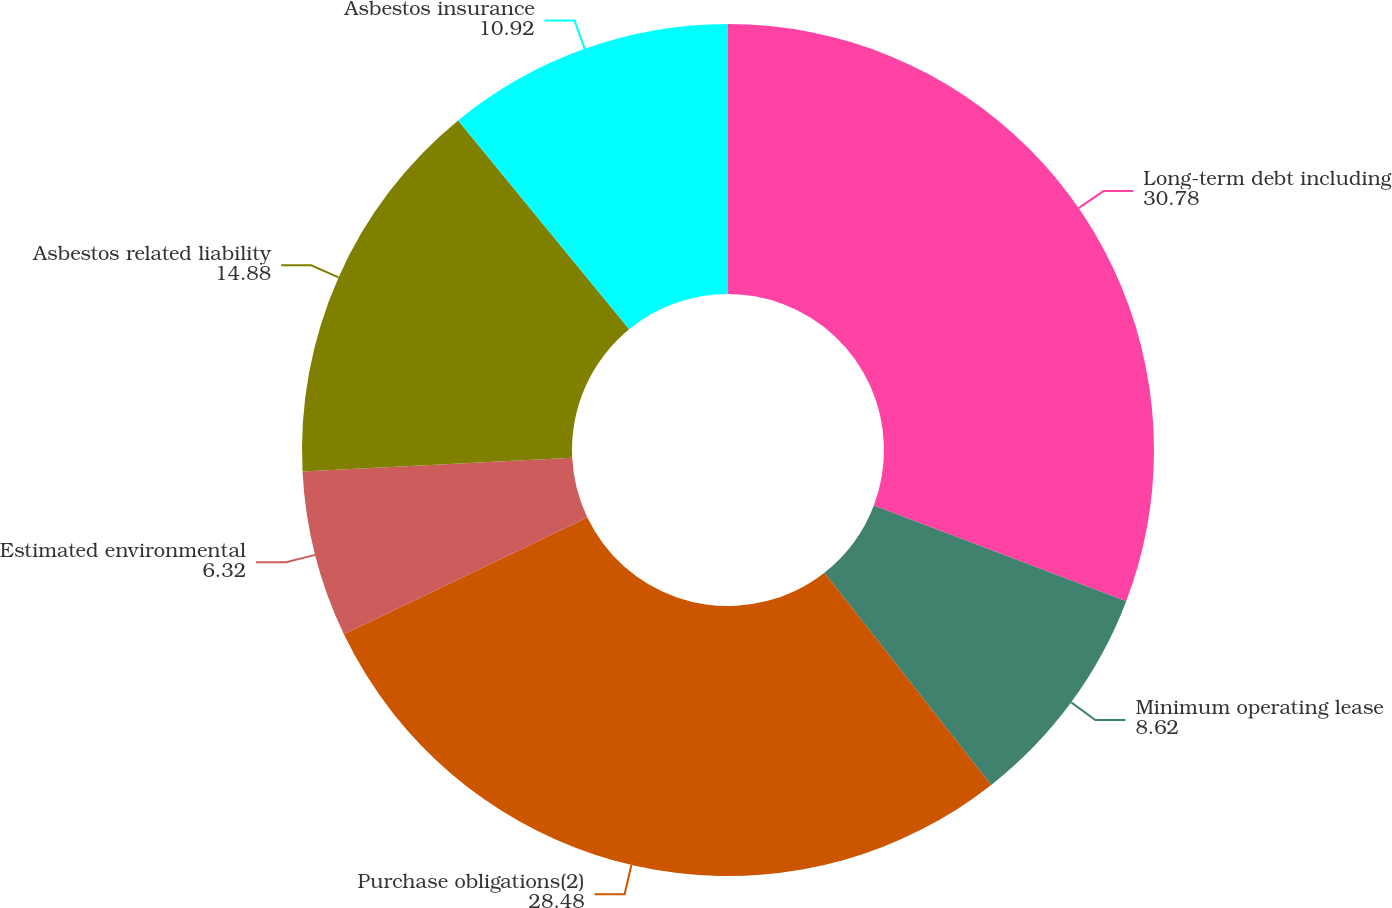Convert chart to OTSL. <chart><loc_0><loc_0><loc_500><loc_500><pie_chart><fcel>Long-term debt including<fcel>Minimum operating lease<fcel>Purchase obligations(2)<fcel>Estimated environmental<fcel>Asbestos related liability<fcel>Asbestos insurance<nl><fcel>30.78%<fcel>8.62%<fcel>28.48%<fcel>6.32%<fcel>14.88%<fcel>10.92%<nl></chart> 